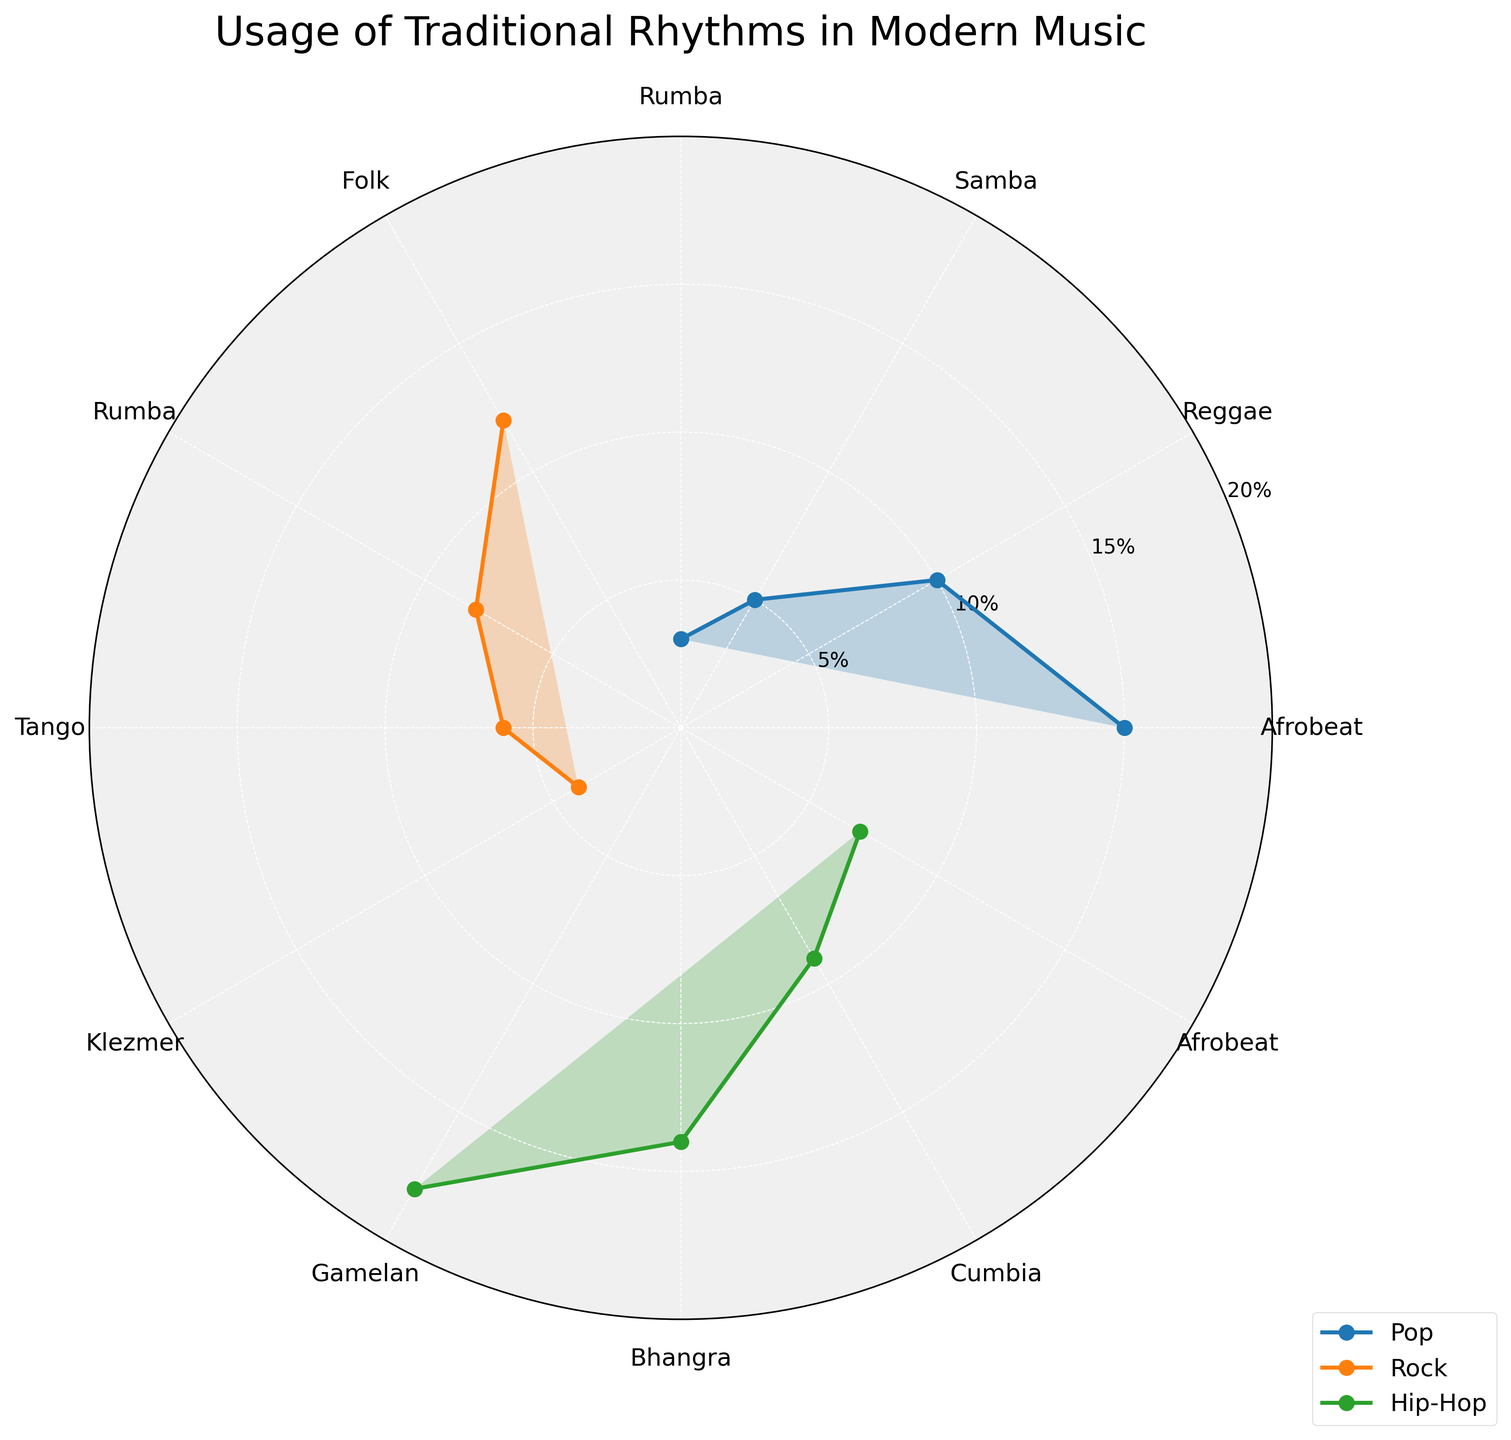What traditional rhythm is used the most in Hip-Hop music? The chart shows that Hip-Hop music uses Gamelan the most, with the highest percentage among the rhythms plotted for this genre.
Answer: Gamelan What is the title of the chart? The title is written at the top center of the chart.
Answer: Usage of Traditional Rhythms in Modern Music Which genre has the lowest usage of Samba rhythm? By looking at the genre categories, only the Pop genre includes Samba, with a usage percentage of 5%. Since none of the other genres use Samba, Pop has the lowest usage.
Answer: Pop How much more of Afrobeat is used in Pop compared to Hip-Hop? Afrobeat usage in Pop is 15%, while it is 7% in Hip-Hop. The difference is 15% - 7%.
Answer: 8% Which traditional rhythm has the highest usage percentage across all genres? The rhythm with the highest usage percentage across all genres is Gamelan in Hip-Hop, with an 18% usage rate.
Answer: Gamelan Is there a rhythm that is used in both Pop and Hip-Hop genres? By closely examining the rhythms for these two genres, we see that both Pop and Hip-Hop use Afrobeat.
Answer: Yes, Afrobeat How many different rhythms are depicted in the chart for Rock genre? By counting the different rhythm labels around the rose chart specific to Rock (Folk, Rumba, Tango, Klezmer), we see there are four rhythms represented.
Answer: 4 Which rhythm is uniquely used by the Rock genre? The chart shows that among the rhythms plotted for Rock, only Folk is used exclusively by the Rock genre.
Answer: Folk Do any genres use Rumba, and if so, which genres? The chart shows that Rumba is used in both Pop and Rock genres.
Answer: Yes, Pop and Rock 